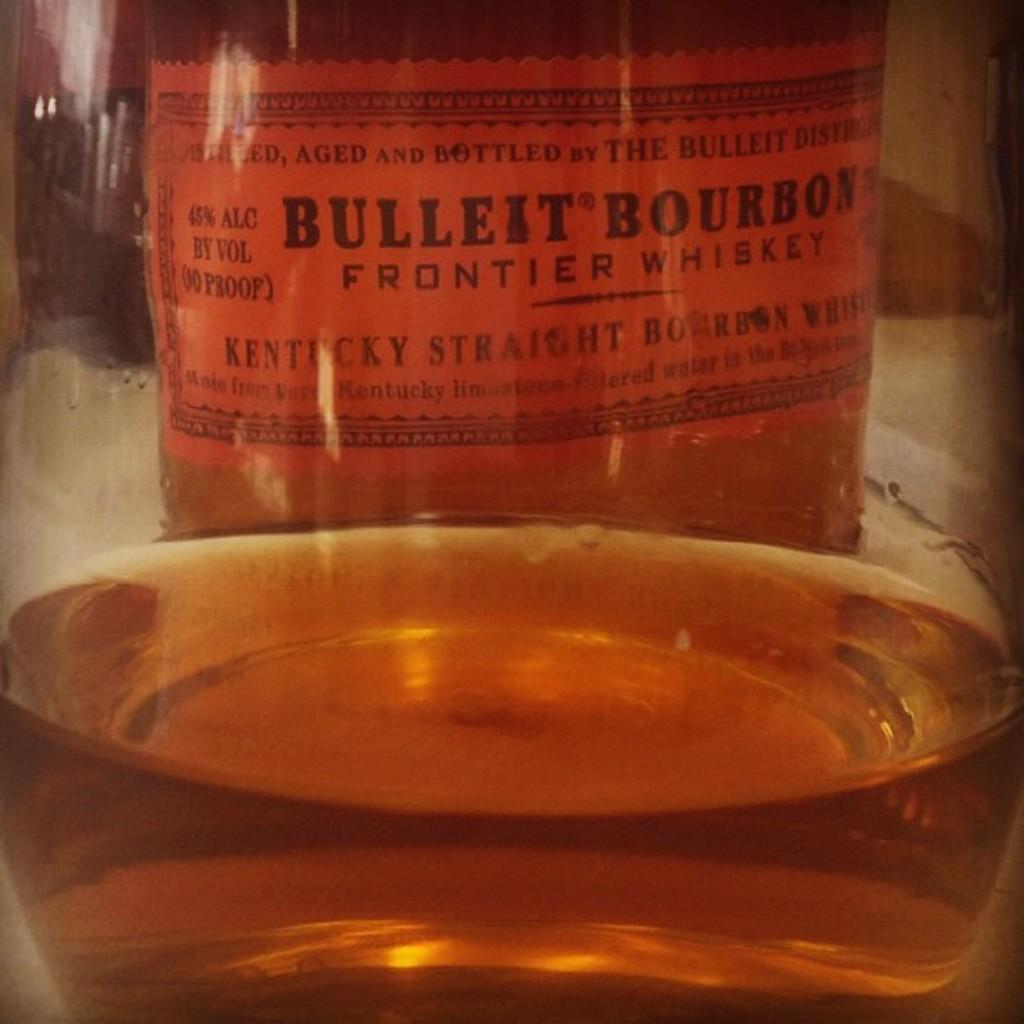What kind of whiskey is this?
Your answer should be very brief. Bulleit bourbon. What brand is this whiskey?
Your response must be concise. Bulleit bourbon. 